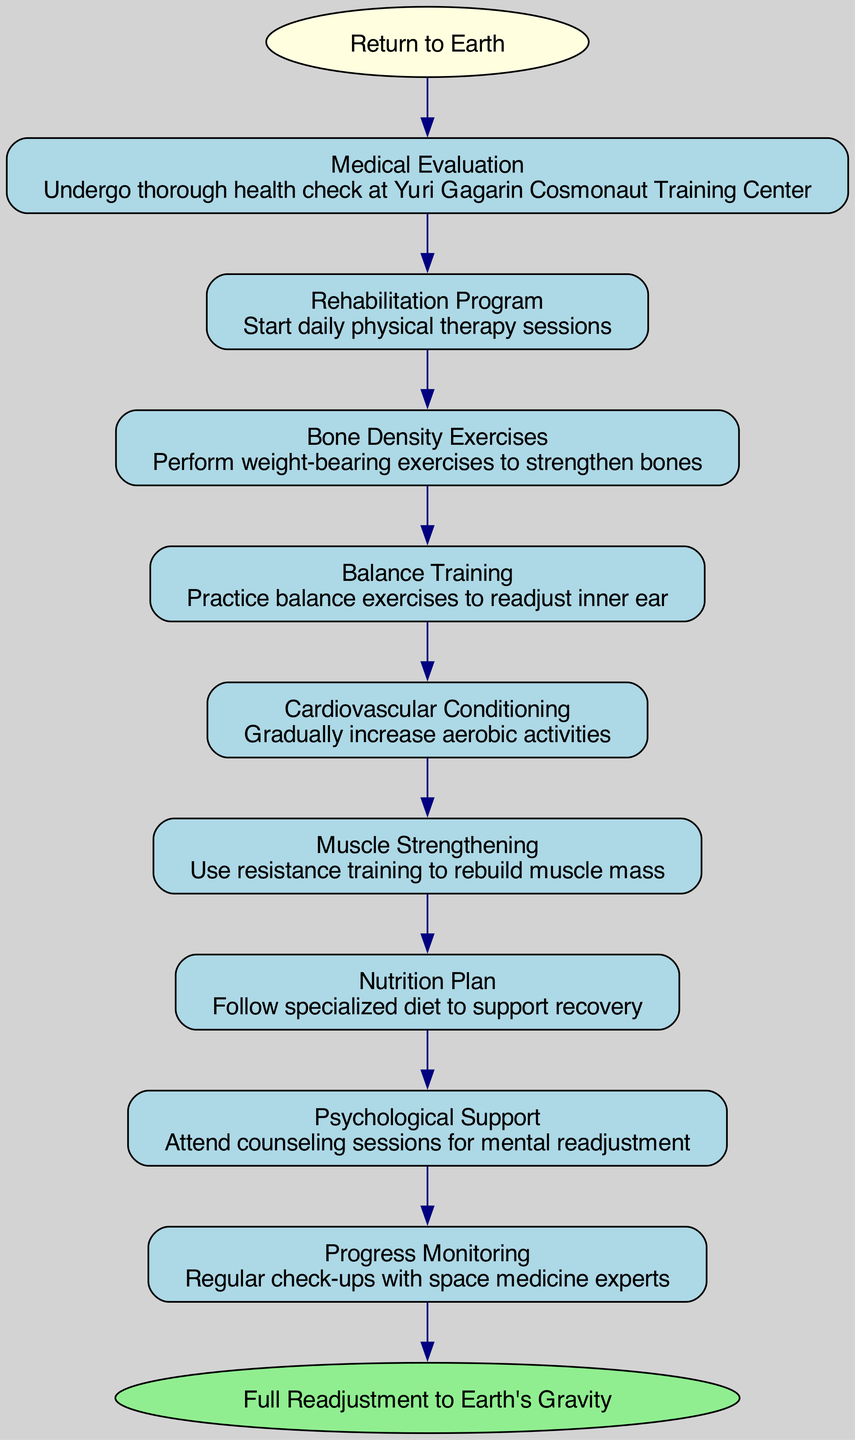What is the starting point of the process? The diagram begins with the node labeled "Return to Earth." This is the first action that initiates the readjustment process after long-term space missions.
Answer: Return to Earth How many steps are in the readjustment process? There are nine steps listed in the diagram that detail the process of readjusting to Earth's gravity after a space mission.
Answer: Nine What is the final stage of the process? The diagram concludes with the node labeled "Full Readjustment to Earth's Gravity," indicating that this is the target outcome of the entire process.
Answer: Full Readjustment to Earth's Gravity What node follows the "Medical Evaluation" step? The "Rehabilitation Program" step follows directly after "Medical Evaluation," forming a sequential flow in the readjustment process.
Answer: Rehabilitation Program Which step focuses on improving muscle mass? The "Muscle Strengthening" step is specifically aimed at using resistance training to rebuild lost muscle mass during the absence of Earth's gravity.
Answer: Muscle Strengthening How does "Nutrition Plan" relate to the other steps? The "Nutrition Plan" is part of the support structure for recovery and is designed to be followed concurrently with other physical rehabilitation activities to enhance overall recovery.
Answer: Support structure for recovery Identify the step that addresses mental health. The "Psychological Support" step is dedicated to mental readjustment, aligning with the need for psychological well-being during the recovery process.
Answer: Psychological Support In what order does "Balance Training" occur relative to "Bone Density Exercises"? "Balance Training" occurs after "Bone Density Exercises" in the sequential flow, emphasizing the importance of both bone health and balance in recovery.
Answer: After What type of training is included before "Cardiovascular Conditioning"? The step "Balance Training" includes balance exercises that help readjust the inner ear before the subsequent focus on increasing aerobic activities in "Cardiovascular Conditioning."
Answer: Balance Training 